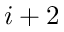Convert formula to latex. <formula><loc_0><loc_0><loc_500><loc_500>i + 2</formula> 